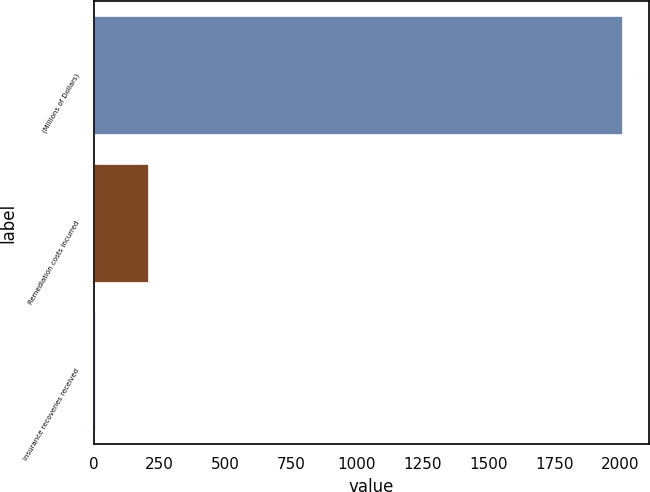Convert chart to OTSL. <chart><loc_0><loc_0><loc_500><loc_500><bar_chart><fcel>(Millions of Dollars)<fcel>Remediation costs incurred<fcel>Insurance recoveries received<nl><fcel>2009<fcel>204.5<fcel>4<nl></chart> 